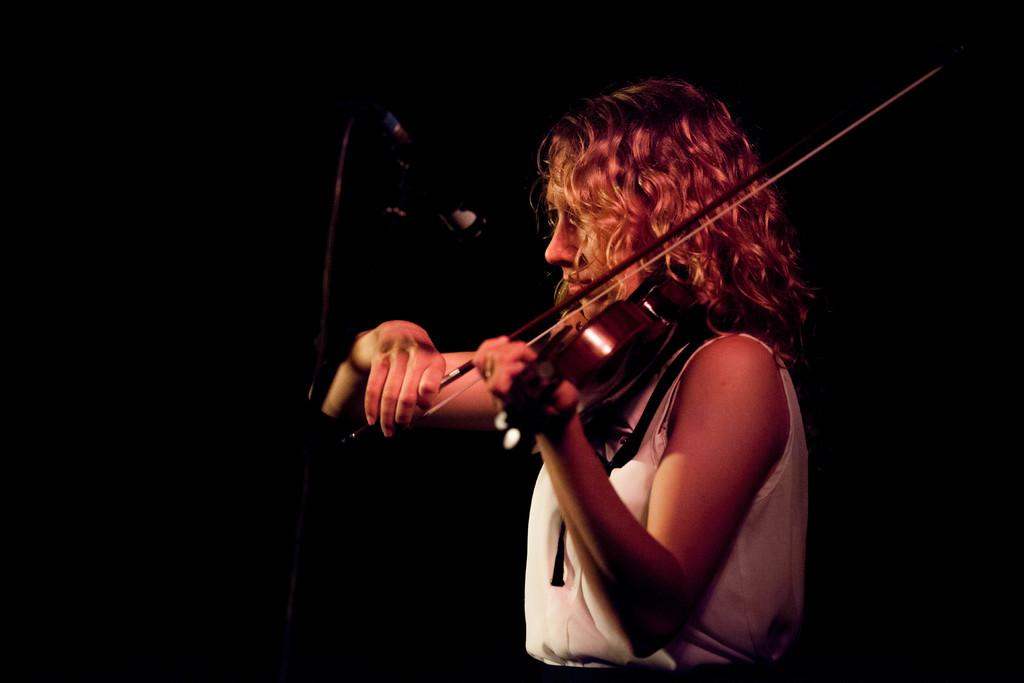Who is the main subject in the image? There is a woman in the image. What is the woman doing in the image? The woman is playing a musical instrument. What object is in front of the woman? There is a mic in front of the woman. What type of yoke is the woman using to play the musical instrument? There is no yoke present in the image, and the woman is not using any yoke to play the musical instrument. 